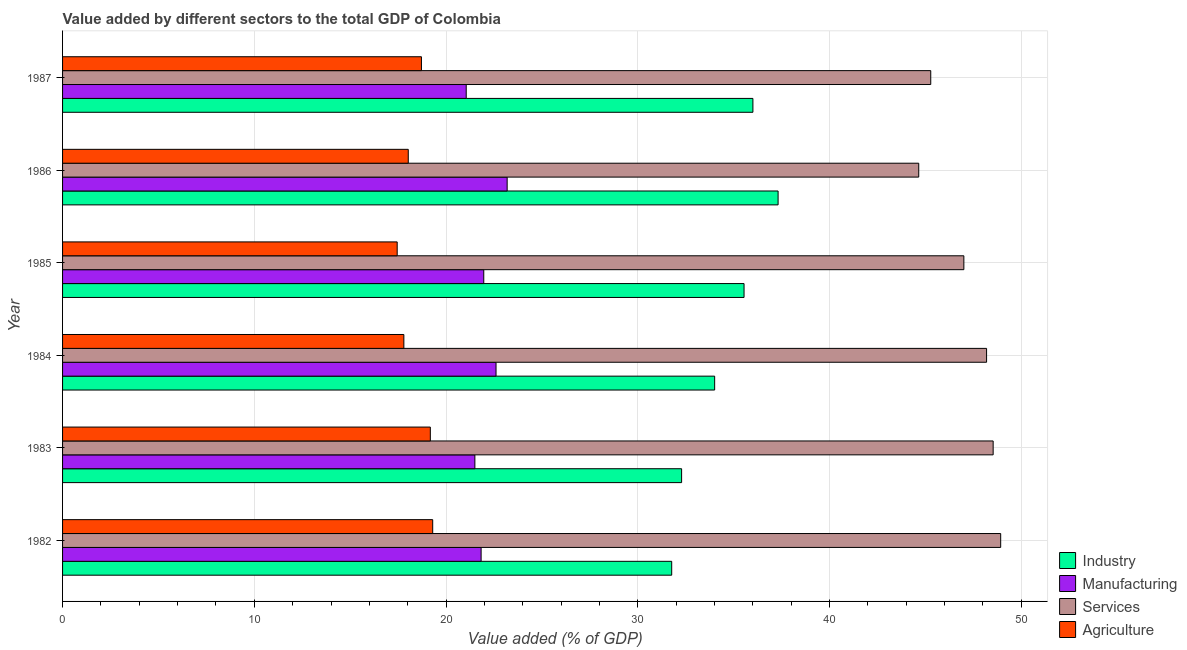How many different coloured bars are there?
Offer a terse response. 4. How many groups of bars are there?
Your answer should be very brief. 6. How many bars are there on the 3rd tick from the top?
Offer a terse response. 4. How many bars are there on the 5th tick from the bottom?
Give a very brief answer. 4. What is the label of the 2nd group of bars from the top?
Offer a terse response. 1986. In how many cases, is the number of bars for a given year not equal to the number of legend labels?
Give a very brief answer. 0. What is the value added by agricultural sector in 1983?
Offer a terse response. 19.18. Across all years, what is the maximum value added by services sector?
Make the answer very short. 48.93. Across all years, what is the minimum value added by services sector?
Ensure brevity in your answer.  44.65. In which year was the value added by agricultural sector maximum?
Your response must be concise. 1982. What is the total value added by industrial sector in the graph?
Offer a terse response. 206.93. What is the difference between the value added by services sector in 1982 and that in 1984?
Give a very brief answer. 0.74. What is the difference between the value added by services sector in 1985 and the value added by industrial sector in 1983?
Your answer should be very brief. 14.72. What is the average value added by services sector per year?
Make the answer very short. 47.1. In the year 1987, what is the difference between the value added by manufacturing sector and value added by industrial sector?
Make the answer very short. -14.95. What is the ratio of the value added by services sector in 1982 to that in 1987?
Ensure brevity in your answer.  1.08. Is the value added by manufacturing sector in 1985 less than that in 1987?
Your answer should be compact. No. Is the difference between the value added by services sector in 1984 and 1987 greater than the difference between the value added by industrial sector in 1984 and 1987?
Your answer should be very brief. Yes. What is the difference between the highest and the second highest value added by agricultural sector?
Give a very brief answer. 0.12. What is the difference between the highest and the lowest value added by manufacturing sector?
Provide a short and direct response. 2.14. In how many years, is the value added by manufacturing sector greater than the average value added by manufacturing sector taken over all years?
Give a very brief answer. 2. Is the sum of the value added by agricultural sector in 1983 and 1987 greater than the maximum value added by services sector across all years?
Provide a short and direct response. No. Is it the case that in every year, the sum of the value added by services sector and value added by manufacturing sector is greater than the sum of value added by industrial sector and value added by agricultural sector?
Keep it short and to the point. No. What does the 1st bar from the top in 1987 represents?
Provide a short and direct response. Agriculture. What does the 3rd bar from the bottom in 1982 represents?
Give a very brief answer. Services. Are all the bars in the graph horizontal?
Give a very brief answer. Yes. Are the values on the major ticks of X-axis written in scientific E-notation?
Your answer should be compact. No. Does the graph contain any zero values?
Your answer should be very brief. No. Where does the legend appear in the graph?
Give a very brief answer. Bottom right. How many legend labels are there?
Your response must be concise. 4. How are the legend labels stacked?
Provide a succinct answer. Vertical. What is the title of the graph?
Offer a very short reply. Value added by different sectors to the total GDP of Colombia. What is the label or title of the X-axis?
Provide a succinct answer. Value added (% of GDP). What is the Value added (% of GDP) in Industry in 1982?
Your answer should be compact. 31.77. What is the Value added (% of GDP) in Manufacturing in 1982?
Provide a short and direct response. 21.83. What is the Value added (% of GDP) in Services in 1982?
Ensure brevity in your answer.  48.93. What is the Value added (% of GDP) in Agriculture in 1982?
Your answer should be compact. 19.3. What is the Value added (% of GDP) of Industry in 1983?
Provide a succinct answer. 32.29. What is the Value added (% of GDP) in Manufacturing in 1983?
Offer a very short reply. 21.5. What is the Value added (% of GDP) of Services in 1983?
Offer a terse response. 48.53. What is the Value added (% of GDP) in Agriculture in 1983?
Provide a succinct answer. 19.18. What is the Value added (% of GDP) of Industry in 1984?
Your answer should be very brief. 34.01. What is the Value added (% of GDP) in Manufacturing in 1984?
Your response must be concise. 22.61. What is the Value added (% of GDP) of Services in 1984?
Offer a terse response. 48.19. What is the Value added (% of GDP) in Agriculture in 1984?
Offer a terse response. 17.8. What is the Value added (% of GDP) in Industry in 1985?
Give a very brief answer. 35.54. What is the Value added (% of GDP) of Manufacturing in 1985?
Ensure brevity in your answer.  21.97. What is the Value added (% of GDP) in Services in 1985?
Your answer should be compact. 47.01. What is the Value added (% of GDP) in Agriculture in 1985?
Make the answer very short. 17.45. What is the Value added (% of GDP) of Industry in 1986?
Your answer should be very brief. 37.32. What is the Value added (% of GDP) of Manufacturing in 1986?
Offer a terse response. 23.19. What is the Value added (% of GDP) of Services in 1986?
Offer a terse response. 44.65. What is the Value added (% of GDP) of Agriculture in 1986?
Give a very brief answer. 18.03. What is the Value added (% of GDP) of Industry in 1987?
Provide a succinct answer. 36. What is the Value added (% of GDP) in Manufacturing in 1987?
Your answer should be compact. 21.05. What is the Value added (% of GDP) of Services in 1987?
Offer a very short reply. 45.28. What is the Value added (% of GDP) in Agriculture in 1987?
Provide a short and direct response. 18.72. Across all years, what is the maximum Value added (% of GDP) in Industry?
Ensure brevity in your answer.  37.32. Across all years, what is the maximum Value added (% of GDP) of Manufacturing?
Offer a terse response. 23.19. Across all years, what is the maximum Value added (% of GDP) in Services?
Ensure brevity in your answer.  48.93. Across all years, what is the maximum Value added (% of GDP) in Agriculture?
Your answer should be very brief. 19.3. Across all years, what is the minimum Value added (% of GDP) in Industry?
Make the answer very short. 31.77. Across all years, what is the minimum Value added (% of GDP) of Manufacturing?
Provide a succinct answer. 21.05. Across all years, what is the minimum Value added (% of GDP) of Services?
Your response must be concise. 44.65. Across all years, what is the minimum Value added (% of GDP) of Agriculture?
Ensure brevity in your answer.  17.45. What is the total Value added (% of GDP) of Industry in the graph?
Your answer should be compact. 206.93. What is the total Value added (% of GDP) of Manufacturing in the graph?
Give a very brief answer. 132.15. What is the total Value added (% of GDP) of Services in the graph?
Offer a terse response. 282.59. What is the total Value added (% of GDP) in Agriculture in the graph?
Give a very brief answer. 110.48. What is the difference between the Value added (% of GDP) in Industry in 1982 and that in 1983?
Make the answer very short. -0.52. What is the difference between the Value added (% of GDP) of Manufacturing in 1982 and that in 1983?
Offer a very short reply. 0.33. What is the difference between the Value added (% of GDP) in Services in 1982 and that in 1983?
Ensure brevity in your answer.  0.39. What is the difference between the Value added (% of GDP) in Agriculture in 1982 and that in 1983?
Provide a succinct answer. 0.12. What is the difference between the Value added (% of GDP) in Industry in 1982 and that in 1984?
Provide a short and direct response. -2.24. What is the difference between the Value added (% of GDP) in Manufacturing in 1982 and that in 1984?
Offer a terse response. -0.78. What is the difference between the Value added (% of GDP) of Services in 1982 and that in 1984?
Provide a short and direct response. 0.74. What is the difference between the Value added (% of GDP) of Agriculture in 1982 and that in 1984?
Give a very brief answer. 1.5. What is the difference between the Value added (% of GDP) in Industry in 1982 and that in 1985?
Make the answer very short. -3.77. What is the difference between the Value added (% of GDP) in Manufacturing in 1982 and that in 1985?
Offer a terse response. -0.14. What is the difference between the Value added (% of GDP) of Services in 1982 and that in 1985?
Your answer should be very brief. 1.92. What is the difference between the Value added (% of GDP) of Agriculture in 1982 and that in 1985?
Your response must be concise. 1.85. What is the difference between the Value added (% of GDP) in Industry in 1982 and that in 1986?
Keep it short and to the point. -5.55. What is the difference between the Value added (% of GDP) in Manufacturing in 1982 and that in 1986?
Your answer should be very brief. -1.36. What is the difference between the Value added (% of GDP) of Services in 1982 and that in 1986?
Offer a terse response. 4.27. What is the difference between the Value added (% of GDP) of Agriculture in 1982 and that in 1986?
Your answer should be compact. 1.27. What is the difference between the Value added (% of GDP) in Industry in 1982 and that in 1987?
Offer a terse response. -4.23. What is the difference between the Value added (% of GDP) in Manufacturing in 1982 and that in 1987?
Offer a terse response. 0.78. What is the difference between the Value added (% of GDP) of Services in 1982 and that in 1987?
Keep it short and to the point. 3.65. What is the difference between the Value added (% of GDP) of Agriculture in 1982 and that in 1987?
Your answer should be very brief. 0.59. What is the difference between the Value added (% of GDP) of Industry in 1983 and that in 1984?
Your response must be concise. -1.72. What is the difference between the Value added (% of GDP) in Manufacturing in 1983 and that in 1984?
Give a very brief answer. -1.1. What is the difference between the Value added (% of GDP) of Services in 1983 and that in 1984?
Give a very brief answer. 0.34. What is the difference between the Value added (% of GDP) of Agriculture in 1983 and that in 1984?
Offer a very short reply. 1.38. What is the difference between the Value added (% of GDP) of Industry in 1983 and that in 1985?
Give a very brief answer. -3.26. What is the difference between the Value added (% of GDP) of Manufacturing in 1983 and that in 1985?
Your answer should be compact. -0.46. What is the difference between the Value added (% of GDP) in Services in 1983 and that in 1985?
Give a very brief answer. 1.53. What is the difference between the Value added (% of GDP) of Agriculture in 1983 and that in 1985?
Your response must be concise. 1.73. What is the difference between the Value added (% of GDP) of Industry in 1983 and that in 1986?
Keep it short and to the point. -5.03. What is the difference between the Value added (% of GDP) in Manufacturing in 1983 and that in 1986?
Provide a succinct answer. -1.68. What is the difference between the Value added (% of GDP) of Services in 1983 and that in 1986?
Give a very brief answer. 3.88. What is the difference between the Value added (% of GDP) in Agriculture in 1983 and that in 1986?
Your answer should be compact. 1.15. What is the difference between the Value added (% of GDP) in Industry in 1983 and that in 1987?
Your answer should be very brief. -3.72. What is the difference between the Value added (% of GDP) of Manufacturing in 1983 and that in 1987?
Ensure brevity in your answer.  0.45. What is the difference between the Value added (% of GDP) in Services in 1983 and that in 1987?
Your response must be concise. 3.26. What is the difference between the Value added (% of GDP) in Agriculture in 1983 and that in 1987?
Make the answer very short. 0.46. What is the difference between the Value added (% of GDP) in Industry in 1984 and that in 1985?
Your answer should be very brief. -1.53. What is the difference between the Value added (% of GDP) in Manufacturing in 1984 and that in 1985?
Ensure brevity in your answer.  0.64. What is the difference between the Value added (% of GDP) in Services in 1984 and that in 1985?
Make the answer very short. 1.19. What is the difference between the Value added (% of GDP) of Agriculture in 1984 and that in 1985?
Ensure brevity in your answer.  0.35. What is the difference between the Value added (% of GDP) in Industry in 1984 and that in 1986?
Provide a short and direct response. -3.31. What is the difference between the Value added (% of GDP) of Manufacturing in 1984 and that in 1986?
Provide a short and direct response. -0.58. What is the difference between the Value added (% of GDP) in Services in 1984 and that in 1986?
Ensure brevity in your answer.  3.54. What is the difference between the Value added (% of GDP) in Agriculture in 1984 and that in 1986?
Your answer should be very brief. -0.23. What is the difference between the Value added (% of GDP) in Industry in 1984 and that in 1987?
Your response must be concise. -1.99. What is the difference between the Value added (% of GDP) of Manufacturing in 1984 and that in 1987?
Provide a succinct answer. 1.56. What is the difference between the Value added (% of GDP) in Services in 1984 and that in 1987?
Your response must be concise. 2.91. What is the difference between the Value added (% of GDP) in Agriculture in 1984 and that in 1987?
Give a very brief answer. -0.92. What is the difference between the Value added (% of GDP) of Industry in 1985 and that in 1986?
Make the answer very short. -1.78. What is the difference between the Value added (% of GDP) of Manufacturing in 1985 and that in 1986?
Provide a succinct answer. -1.22. What is the difference between the Value added (% of GDP) in Services in 1985 and that in 1986?
Offer a very short reply. 2.35. What is the difference between the Value added (% of GDP) in Agriculture in 1985 and that in 1986?
Your answer should be very brief. -0.58. What is the difference between the Value added (% of GDP) of Industry in 1985 and that in 1987?
Provide a short and direct response. -0.46. What is the difference between the Value added (% of GDP) in Manufacturing in 1985 and that in 1987?
Ensure brevity in your answer.  0.92. What is the difference between the Value added (% of GDP) of Services in 1985 and that in 1987?
Your answer should be compact. 1.73. What is the difference between the Value added (% of GDP) of Agriculture in 1985 and that in 1987?
Your answer should be very brief. -1.26. What is the difference between the Value added (% of GDP) of Industry in 1986 and that in 1987?
Ensure brevity in your answer.  1.31. What is the difference between the Value added (% of GDP) of Manufacturing in 1986 and that in 1987?
Your answer should be very brief. 2.14. What is the difference between the Value added (% of GDP) of Services in 1986 and that in 1987?
Offer a very short reply. -0.63. What is the difference between the Value added (% of GDP) in Agriculture in 1986 and that in 1987?
Keep it short and to the point. -0.69. What is the difference between the Value added (% of GDP) in Industry in 1982 and the Value added (% of GDP) in Manufacturing in 1983?
Your response must be concise. 10.27. What is the difference between the Value added (% of GDP) in Industry in 1982 and the Value added (% of GDP) in Services in 1983?
Your response must be concise. -16.77. What is the difference between the Value added (% of GDP) of Industry in 1982 and the Value added (% of GDP) of Agriculture in 1983?
Your answer should be very brief. 12.59. What is the difference between the Value added (% of GDP) in Manufacturing in 1982 and the Value added (% of GDP) in Services in 1983?
Offer a terse response. -26.71. What is the difference between the Value added (% of GDP) in Manufacturing in 1982 and the Value added (% of GDP) in Agriculture in 1983?
Your response must be concise. 2.65. What is the difference between the Value added (% of GDP) of Services in 1982 and the Value added (% of GDP) of Agriculture in 1983?
Your answer should be compact. 29.75. What is the difference between the Value added (% of GDP) of Industry in 1982 and the Value added (% of GDP) of Manufacturing in 1984?
Your response must be concise. 9.16. What is the difference between the Value added (% of GDP) of Industry in 1982 and the Value added (% of GDP) of Services in 1984?
Provide a short and direct response. -16.42. What is the difference between the Value added (% of GDP) in Industry in 1982 and the Value added (% of GDP) in Agriculture in 1984?
Provide a short and direct response. 13.97. What is the difference between the Value added (% of GDP) of Manufacturing in 1982 and the Value added (% of GDP) of Services in 1984?
Offer a very short reply. -26.36. What is the difference between the Value added (% of GDP) in Manufacturing in 1982 and the Value added (% of GDP) in Agriculture in 1984?
Keep it short and to the point. 4.03. What is the difference between the Value added (% of GDP) in Services in 1982 and the Value added (% of GDP) in Agriculture in 1984?
Keep it short and to the point. 31.13. What is the difference between the Value added (% of GDP) of Industry in 1982 and the Value added (% of GDP) of Manufacturing in 1985?
Offer a very short reply. 9.8. What is the difference between the Value added (% of GDP) in Industry in 1982 and the Value added (% of GDP) in Services in 1985?
Offer a terse response. -15.24. What is the difference between the Value added (% of GDP) in Industry in 1982 and the Value added (% of GDP) in Agriculture in 1985?
Make the answer very short. 14.32. What is the difference between the Value added (% of GDP) in Manufacturing in 1982 and the Value added (% of GDP) in Services in 1985?
Ensure brevity in your answer.  -25.18. What is the difference between the Value added (% of GDP) of Manufacturing in 1982 and the Value added (% of GDP) of Agriculture in 1985?
Your response must be concise. 4.38. What is the difference between the Value added (% of GDP) of Services in 1982 and the Value added (% of GDP) of Agriculture in 1985?
Ensure brevity in your answer.  31.48. What is the difference between the Value added (% of GDP) of Industry in 1982 and the Value added (% of GDP) of Manufacturing in 1986?
Make the answer very short. 8.58. What is the difference between the Value added (% of GDP) of Industry in 1982 and the Value added (% of GDP) of Services in 1986?
Make the answer very short. -12.88. What is the difference between the Value added (% of GDP) in Industry in 1982 and the Value added (% of GDP) in Agriculture in 1986?
Your answer should be compact. 13.74. What is the difference between the Value added (% of GDP) of Manufacturing in 1982 and the Value added (% of GDP) of Services in 1986?
Your answer should be compact. -22.82. What is the difference between the Value added (% of GDP) of Manufacturing in 1982 and the Value added (% of GDP) of Agriculture in 1986?
Offer a terse response. 3.8. What is the difference between the Value added (% of GDP) in Services in 1982 and the Value added (% of GDP) in Agriculture in 1986?
Keep it short and to the point. 30.9. What is the difference between the Value added (% of GDP) in Industry in 1982 and the Value added (% of GDP) in Manufacturing in 1987?
Keep it short and to the point. 10.72. What is the difference between the Value added (% of GDP) in Industry in 1982 and the Value added (% of GDP) in Services in 1987?
Make the answer very short. -13.51. What is the difference between the Value added (% of GDP) in Industry in 1982 and the Value added (% of GDP) in Agriculture in 1987?
Give a very brief answer. 13.05. What is the difference between the Value added (% of GDP) of Manufacturing in 1982 and the Value added (% of GDP) of Services in 1987?
Provide a succinct answer. -23.45. What is the difference between the Value added (% of GDP) of Manufacturing in 1982 and the Value added (% of GDP) of Agriculture in 1987?
Make the answer very short. 3.11. What is the difference between the Value added (% of GDP) of Services in 1982 and the Value added (% of GDP) of Agriculture in 1987?
Ensure brevity in your answer.  30.21. What is the difference between the Value added (% of GDP) of Industry in 1983 and the Value added (% of GDP) of Manufacturing in 1984?
Provide a short and direct response. 9.68. What is the difference between the Value added (% of GDP) of Industry in 1983 and the Value added (% of GDP) of Services in 1984?
Your answer should be compact. -15.91. What is the difference between the Value added (% of GDP) in Industry in 1983 and the Value added (% of GDP) in Agriculture in 1984?
Your answer should be very brief. 14.49. What is the difference between the Value added (% of GDP) in Manufacturing in 1983 and the Value added (% of GDP) in Services in 1984?
Offer a terse response. -26.69. What is the difference between the Value added (% of GDP) in Manufacturing in 1983 and the Value added (% of GDP) in Agriculture in 1984?
Provide a succinct answer. 3.7. What is the difference between the Value added (% of GDP) in Services in 1983 and the Value added (% of GDP) in Agriculture in 1984?
Ensure brevity in your answer.  30.73. What is the difference between the Value added (% of GDP) of Industry in 1983 and the Value added (% of GDP) of Manufacturing in 1985?
Ensure brevity in your answer.  10.32. What is the difference between the Value added (% of GDP) of Industry in 1983 and the Value added (% of GDP) of Services in 1985?
Ensure brevity in your answer.  -14.72. What is the difference between the Value added (% of GDP) in Industry in 1983 and the Value added (% of GDP) in Agriculture in 1985?
Your answer should be compact. 14.83. What is the difference between the Value added (% of GDP) of Manufacturing in 1983 and the Value added (% of GDP) of Services in 1985?
Make the answer very short. -25.5. What is the difference between the Value added (% of GDP) in Manufacturing in 1983 and the Value added (% of GDP) in Agriculture in 1985?
Make the answer very short. 4.05. What is the difference between the Value added (% of GDP) of Services in 1983 and the Value added (% of GDP) of Agriculture in 1985?
Your answer should be very brief. 31.08. What is the difference between the Value added (% of GDP) of Industry in 1983 and the Value added (% of GDP) of Manufacturing in 1986?
Offer a terse response. 9.1. What is the difference between the Value added (% of GDP) of Industry in 1983 and the Value added (% of GDP) of Services in 1986?
Ensure brevity in your answer.  -12.37. What is the difference between the Value added (% of GDP) in Industry in 1983 and the Value added (% of GDP) in Agriculture in 1986?
Give a very brief answer. 14.26. What is the difference between the Value added (% of GDP) of Manufacturing in 1983 and the Value added (% of GDP) of Services in 1986?
Your answer should be compact. -23.15. What is the difference between the Value added (% of GDP) of Manufacturing in 1983 and the Value added (% of GDP) of Agriculture in 1986?
Provide a short and direct response. 3.47. What is the difference between the Value added (% of GDP) of Services in 1983 and the Value added (% of GDP) of Agriculture in 1986?
Your response must be concise. 30.5. What is the difference between the Value added (% of GDP) of Industry in 1983 and the Value added (% of GDP) of Manufacturing in 1987?
Provide a succinct answer. 11.23. What is the difference between the Value added (% of GDP) in Industry in 1983 and the Value added (% of GDP) in Services in 1987?
Your response must be concise. -12.99. What is the difference between the Value added (% of GDP) in Industry in 1983 and the Value added (% of GDP) in Agriculture in 1987?
Ensure brevity in your answer.  13.57. What is the difference between the Value added (% of GDP) in Manufacturing in 1983 and the Value added (% of GDP) in Services in 1987?
Provide a short and direct response. -23.78. What is the difference between the Value added (% of GDP) in Manufacturing in 1983 and the Value added (% of GDP) in Agriculture in 1987?
Provide a short and direct response. 2.79. What is the difference between the Value added (% of GDP) of Services in 1983 and the Value added (% of GDP) of Agriculture in 1987?
Make the answer very short. 29.82. What is the difference between the Value added (% of GDP) of Industry in 1984 and the Value added (% of GDP) of Manufacturing in 1985?
Keep it short and to the point. 12.04. What is the difference between the Value added (% of GDP) in Industry in 1984 and the Value added (% of GDP) in Services in 1985?
Offer a terse response. -13. What is the difference between the Value added (% of GDP) of Industry in 1984 and the Value added (% of GDP) of Agriculture in 1985?
Give a very brief answer. 16.56. What is the difference between the Value added (% of GDP) of Manufacturing in 1984 and the Value added (% of GDP) of Services in 1985?
Provide a short and direct response. -24.4. What is the difference between the Value added (% of GDP) in Manufacturing in 1984 and the Value added (% of GDP) in Agriculture in 1985?
Provide a succinct answer. 5.16. What is the difference between the Value added (% of GDP) in Services in 1984 and the Value added (% of GDP) in Agriculture in 1985?
Offer a terse response. 30.74. What is the difference between the Value added (% of GDP) of Industry in 1984 and the Value added (% of GDP) of Manufacturing in 1986?
Make the answer very short. 10.82. What is the difference between the Value added (% of GDP) in Industry in 1984 and the Value added (% of GDP) in Services in 1986?
Offer a very short reply. -10.64. What is the difference between the Value added (% of GDP) in Industry in 1984 and the Value added (% of GDP) in Agriculture in 1986?
Your response must be concise. 15.98. What is the difference between the Value added (% of GDP) in Manufacturing in 1984 and the Value added (% of GDP) in Services in 1986?
Your response must be concise. -22.05. What is the difference between the Value added (% of GDP) of Manufacturing in 1984 and the Value added (% of GDP) of Agriculture in 1986?
Your answer should be very brief. 4.58. What is the difference between the Value added (% of GDP) of Services in 1984 and the Value added (% of GDP) of Agriculture in 1986?
Provide a short and direct response. 30.16. What is the difference between the Value added (% of GDP) in Industry in 1984 and the Value added (% of GDP) in Manufacturing in 1987?
Ensure brevity in your answer.  12.96. What is the difference between the Value added (% of GDP) in Industry in 1984 and the Value added (% of GDP) in Services in 1987?
Your answer should be compact. -11.27. What is the difference between the Value added (% of GDP) in Industry in 1984 and the Value added (% of GDP) in Agriculture in 1987?
Your answer should be compact. 15.29. What is the difference between the Value added (% of GDP) of Manufacturing in 1984 and the Value added (% of GDP) of Services in 1987?
Your answer should be compact. -22.67. What is the difference between the Value added (% of GDP) of Manufacturing in 1984 and the Value added (% of GDP) of Agriculture in 1987?
Offer a very short reply. 3.89. What is the difference between the Value added (% of GDP) in Services in 1984 and the Value added (% of GDP) in Agriculture in 1987?
Ensure brevity in your answer.  29.47. What is the difference between the Value added (% of GDP) of Industry in 1985 and the Value added (% of GDP) of Manufacturing in 1986?
Your answer should be compact. 12.35. What is the difference between the Value added (% of GDP) of Industry in 1985 and the Value added (% of GDP) of Services in 1986?
Ensure brevity in your answer.  -9.11. What is the difference between the Value added (% of GDP) in Industry in 1985 and the Value added (% of GDP) in Agriculture in 1986?
Offer a terse response. 17.51. What is the difference between the Value added (% of GDP) in Manufacturing in 1985 and the Value added (% of GDP) in Services in 1986?
Offer a very short reply. -22.69. What is the difference between the Value added (% of GDP) in Manufacturing in 1985 and the Value added (% of GDP) in Agriculture in 1986?
Offer a terse response. 3.94. What is the difference between the Value added (% of GDP) in Services in 1985 and the Value added (% of GDP) in Agriculture in 1986?
Offer a terse response. 28.98. What is the difference between the Value added (% of GDP) of Industry in 1985 and the Value added (% of GDP) of Manufacturing in 1987?
Give a very brief answer. 14.49. What is the difference between the Value added (% of GDP) of Industry in 1985 and the Value added (% of GDP) of Services in 1987?
Your answer should be very brief. -9.74. What is the difference between the Value added (% of GDP) in Industry in 1985 and the Value added (% of GDP) in Agriculture in 1987?
Keep it short and to the point. 16.83. What is the difference between the Value added (% of GDP) of Manufacturing in 1985 and the Value added (% of GDP) of Services in 1987?
Offer a terse response. -23.31. What is the difference between the Value added (% of GDP) in Manufacturing in 1985 and the Value added (% of GDP) in Agriculture in 1987?
Offer a terse response. 3.25. What is the difference between the Value added (% of GDP) in Services in 1985 and the Value added (% of GDP) in Agriculture in 1987?
Provide a succinct answer. 28.29. What is the difference between the Value added (% of GDP) in Industry in 1986 and the Value added (% of GDP) in Manufacturing in 1987?
Keep it short and to the point. 16.27. What is the difference between the Value added (% of GDP) in Industry in 1986 and the Value added (% of GDP) in Services in 1987?
Keep it short and to the point. -7.96. What is the difference between the Value added (% of GDP) of Industry in 1986 and the Value added (% of GDP) of Agriculture in 1987?
Keep it short and to the point. 18.6. What is the difference between the Value added (% of GDP) in Manufacturing in 1986 and the Value added (% of GDP) in Services in 1987?
Provide a succinct answer. -22.09. What is the difference between the Value added (% of GDP) of Manufacturing in 1986 and the Value added (% of GDP) of Agriculture in 1987?
Provide a short and direct response. 4.47. What is the difference between the Value added (% of GDP) of Services in 1986 and the Value added (% of GDP) of Agriculture in 1987?
Give a very brief answer. 25.94. What is the average Value added (% of GDP) of Industry per year?
Your answer should be compact. 34.49. What is the average Value added (% of GDP) of Manufacturing per year?
Offer a terse response. 22.02. What is the average Value added (% of GDP) of Services per year?
Ensure brevity in your answer.  47.1. What is the average Value added (% of GDP) in Agriculture per year?
Provide a short and direct response. 18.41. In the year 1982, what is the difference between the Value added (% of GDP) of Industry and Value added (% of GDP) of Manufacturing?
Ensure brevity in your answer.  9.94. In the year 1982, what is the difference between the Value added (% of GDP) in Industry and Value added (% of GDP) in Services?
Ensure brevity in your answer.  -17.16. In the year 1982, what is the difference between the Value added (% of GDP) of Industry and Value added (% of GDP) of Agriculture?
Offer a terse response. 12.47. In the year 1982, what is the difference between the Value added (% of GDP) in Manufacturing and Value added (% of GDP) in Services?
Keep it short and to the point. -27.1. In the year 1982, what is the difference between the Value added (% of GDP) in Manufacturing and Value added (% of GDP) in Agriculture?
Your answer should be compact. 2.53. In the year 1982, what is the difference between the Value added (% of GDP) in Services and Value added (% of GDP) in Agriculture?
Make the answer very short. 29.62. In the year 1983, what is the difference between the Value added (% of GDP) in Industry and Value added (% of GDP) in Manufacturing?
Offer a very short reply. 10.78. In the year 1983, what is the difference between the Value added (% of GDP) of Industry and Value added (% of GDP) of Services?
Provide a short and direct response. -16.25. In the year 1983, what is the difference between the Value added (% of GDP) of Industry and Value added (% of GDP) of Agriculture?
Give a very brief answer. 13.11. In the year 1983, what is the difference between the Value added (% of GDP) of Manufacturing and Value added (% of GDP) of Services?
Give a very brief answer. -27.03. In the year 1983, what is the difference between the Value added (% of GDP) of Manufacturing and Value added (% of GDP) of Agriculture?
Your response must be concise. 2.32. In the year 1983, what is the difference between the Value added (% of GDP) of Services and Value added (% of GDP) of Agriculture?
Ensure brevity in your answer.  29.35. In the year 1984, what is the difference between the Value added (% of GDP) of Industry and Value added (% of GDP) of Manufacturing?
Your answer should be compact. 11.4. In the year 1984, what is the difference between the Value added (% of GDP) in Industry and Value added (% of GDP) in Services?
Offer a very short reply. -14.18. In the year 1984, what is the difference between the Value added (% of GDP) of Industry and Value added (% of GDP) of Agriculture?
Give a very brief answer. 16.21. In the year 1984, what is the difference between the Value added (% of GDP) of Manufacturing and Value added (% of GDP) of Services?
Provide a short and direct response. -25.58. In the year 1984, what is the difference between the Value added (% of GDP) of Manufacturing and Value added (% of GDP) of Agriculture?
Provide a succinct answer. 4.81. In the year 1984, what is the difference between the Value added (% of GDP) in Services and Value added (% of GDP) in Agriculture?
Your response must be concise. 30.39. In the year 1985, what is the difference between the Value added (% of GDP) of Industry and Value added (% of GDP) of Manufacturing?
Ensure brevity in your answer.  13.58. In the year 1985, what is the difference between the Value added (% of GDP) of Industry and Value added (% of GDP) of Services?
Offer a very short reply. -11.46. In the year 1985, what is the difference between the Value added (% of GDP) in Industry and Value added (% of GDP) in Agriculture?
Provide a succinct answer. 18.09. In the year 1985, what is the difference between the Value added (% of GDP) of Manufacturing and Value added (% of GDP) of Services?
Your answer should be very brief. -25.04. In the year 1985, what is the difference between the Value added (% of GDP) of Manufacturing and Value added (% of GDP) of Agriculture?
Ensure brevity in your answer.  4.52. In the year 1985, what is the difference between the Value added (% of GDP) in Services and Value added (% of GDP) in Agriculture?
Offer a terse response. 29.55. In the year 1986, what is the difference between the Value added (% of GDP) of Industry and Value added (% of GDP) of Manufacturing?
Keep it short and to the point. 14.13. In the year 1986, what is the difference between the Value added (% of GDP) in Industry and Value added (% of GDP) in Services?
Your answer should be very brief. -7.33. In the year 1986, what is the difference between the Value added (% of GDP) in Industry and Value added (% of GDP) in Agriculture?
Offer a terse response. 19.29. In the year 1986, what is the difference between the Value added (% of GDP) in Manufacturing and Value added (% of GDP) in Services?
Provide a succinct answer. -21.46. In the year 1986, what is the difference between the Value added (% of GDP) in Manufacturing and Value added (% of GDP) in Agriculture?
Give a very brief answer. 5.16. In the year 1986, what is the difference between the Value added (% of GDP) of Services and Value added (% of GDP) of Agriculture?
Your answer should be very brief. 26.62. In the year 1987, what is the difference between the Value added (% of GDP) in Industry and Value added (% of GDP) in Manufacturing?
Offer a terse response. 14.95. In the year 1987, what is the difference between the Value added (% of GDP) in Industry and Value added (% of GDP) in Services?
Keep it short and to the point. -9.28. In the year 1987, what is the difference between the Value added (% of GDP) of Industry and Value added (% of GDP) of Agriculture?
Provide a succinct answer. 17.29. In the year 1987, what is the difference between the Value added (% of GDP) of Manufacturing and Value added (% of GDP) of Services?
Offer a terse response. -24.23. In the year 1987, what is the difference between the Value added (% of GDP) in Manufacturing and Value added (% of GDP) in Agriculture?
Offer a terse response. 2.34. In the year 1987, what is the difference between the Value added (% of GDP) of Services and Value added (% of GDP) of Agriculture?
Your response must be concise. 26.56. What is the ratio of the Value added (% of GDP) of Industry in 1982 to that in 1983?
Provide a short and direct response. 0.98. What is the ratio of the Value added (% of GDP) in Manufacturing in 1982 to that in 1983?
Offer a very short reply. 1.02. What is the ratio of the Value added (% of GDP) of Services in 1982 to that in 1983?
Provide a short and direct response. 1.01. What is the ratio of the Value added (% of GDP) in Industry in 1982 to that in 1984?
Your answer should be compact. 0.93. What is the ratio of the Value added (% of GDP) in Manufacturing in 1982 to that in 1984?
Offer a terse response. 0.97. What is the ratio of the Value added (% of GDP) of Services in 1982 to that in 1984?
Your answer should be very brief. 1.02. What is the ratio of the Value added (% of GDP) in Agriculture in 1982 to that in 1984?
Offer a terse response. 1.08. What is the ratio of the Value added (% of GDP) of Industry in 1982 to that in 1985?
Ensure brevity in your answer.  0.89. What is the ratio of the Value added (% of GDP) of Services in 1982 to that in 1985?
Offer a very short reply. 1.04. What is the ratio of the Value added (% of GDP) in Agriculture in 1982 to that in 1985?
Ensure brevity in your answer.  1.11. What is the ratio of the Value added (% of GDP) in Industry in 1982 to that in 1986?
Your answer should be very brief. 0.85. What is the ratio of the Value added (% of GDP) in Manufacturing in 1982 to that in 1986?
Give a very brief answer. 0.94. What is the ratio of the Value added (% of GDP) in Services in 1982 to that in 1986?
Keep it short and to the point. 1.1. What is the ratio of the Value added (% of GDP) of Agriculture in 1982 to that in 1986?
Your answer should be very brief. 1.07. What is the ratio of the Value added (% of GDP) of Industry in 1982 to that in 1987?
Give a very brief answer. 0.88. What is the ratio of the Value added (% of GDP) of Manufacturing in 1982 to that in 1987?
Your answer should be very brief. 1.04. What is the ratio of the Value added (% of GDP) of Services in 1982 to that in 1987?
Provide a succinct answer. 1.08. What is the ratio of the Value added (% of GDP) in Agriculture in 1982 to that in 1987?
Your response must be concise. 1.03. What is the ratio of the Value added (% of GDP) in Industry in 1983 to that in 1984?
Provide a short and direct response. 0.95. What is the ratio of the Value added (% of GDP) of Manufacturing in 1983 to that in 1984?
Your answer should be compact. 0.95. What is the ratio of the Value added (% of GDP) in Services in 1983 to that in 1984?
Keep it short and to the point. 1.01. What is the ratio of the Value added (% of GDP) in Agriculture in 1983 to that in 1984?
Offer a terse response. 1.08. What is the ratio of the Value added (% of GDP) of Industry in 1983 to that in 1985?
Offer a terse response. 0.91. What is the ratio of the Value added (% of GDP) of Manufacturing in 1983 to that in 1985?
Make the answer very short. 0.98. What is the ratio of the Value added (% of GDP) in Services in 1983 to that in 1985?
Your response must be concise. 1.03. What is the ratio of the Value added (% of GDP) in Agriculture in 1983 to that in 1985?
Your answer should be very brief. 1.1. What is the ratio of the Value added (% of GDP) of Industry in 1983 to that in 1986?
Your answer should be compact. 0.87. What is the ratio of the Value added (% of GDP) of Manufacturing in 1983 to that in 1986?
Offer a terse response. 0.93. What is the ratio of the Value added (% of GDP) in Services in 1983 to that in 1986?
Your answer should be very brief. 1.09. What is the ratio of the Value added (% of GDP) of Agriculture in 1983 to that in 1986?
Provide a short and direct response. 1.06. What is the ratio of the Value added (% of GDP) in Industry in 1983 to that in 1987?
Offer a terse response. 0.9. What is the ratio of the Value added (% of GDP) of Manufacturing in 1983 to that in 1987?
Your answer should be compact. 1.02. What is the ratio of the Value added (% of GDP) in Services in 1983 to that in 1987?
Your response must be concise. 1.07. What is the ratio of the Value added (% of GDP) of Agriculture in 1983 to that in 1987?
Offer a very short reply. 1.02. What is the ratio of the Value added (% of GDP) of Industry in 1984 to that in 1985?
Provide a succinct answer. 0.96. What is the ratio of the Value added (% of GDP) in Manufacturing in 1984 to that in 1985?
Keep it short and to the point. 1.03. What is the ratio of the Value added (% of GDP) in Services in 1984 to that in 1985?
Your answer should be compact. 1.03. What is the ratio of the Value added (% of GDP) in Industry in 1984 to that in 1986?
Provide a succinct answer. 0.91. What is the ratio of the Value added (% of GDP) of Manufacturing in 1984 to that in 1986?
Keep it short and to the point. 0.97. What is the ratio of the Value added (% of GDP) of Services in 1984 to that in 1986?
Give a very brief answer. 1.08. What is the ratio of the Value added (% of GDP) in Agriculture in 1984 to that in 1986?
Your response must be concise. 0.99. What is the ratio of the Value added (% of GDP) of Industry in 1984 to that in 1987?
Ensure brevity in your answer.  0.94. What is the ratio of the Value added (% of GDP) of Manufacturing in 1984 to that in 1987?
Your answer should be very brief. 1.07. What is the ratio of the Value added (% of GDP) of Services in 1984 to that in 1987?
Give a very brief answer. 1.06. What is the ratio of the Value added (% of GDP) of Agriculture in 1984 to that in 1987?
Offer a very short reply. 0.95. What is the ratio of the Value added (% of GDP) of Industry in 1985 to that in 1986?
Provide a succinct answer. 0.95. What is the ratio of the Value added (% of GDP) of Services in 1985 to that in 1986?
Provide a succinct answer. 1.05. What is the ratio of the Value added (% of GDP) in Agriculture in 1985 to that in 1986?
Ensure brevity in your answer.  0.97. What is the ratio of the Value added (% of GDP) of Industry in 1985 to that in 1987?
Your answer should be compact. 0.99. What is the ratio of the Value added (% of GDP) of Manufacturing in 1985 to that in 1987?
Ensure brevity in your answer.  1.04. What is the ratio of the Value added (% of GDP) in Services in 1985 to that in 1987?
Your answer should be very brief. 1.04. What is the ratio of the Value added (% of GDP) in Agriculture in 1985 to that in 1987?
Offer a very short reply. 0.93. What is the ratio of the Value added (% of GDP) in Industry in 1986 to that in 1987?
Give a very brief answer. 1.04. What is the ratio of the Value added (% of GDP) of Manufacturing in 1986 to that in 1987?
Keep it short and to the point. 1.1. What is the ratio of the Value added (% of GDP) in Services in 1986 to that in 1987?
Your answer should be very brief. 0.99. What is the ratio of the Value added (% of GDP) of Agriculture in 1986 to that in 1987?
Offer a terse response. 0.96. What is the difference between the highest and the second highest Value added (% of GDP) of Industry?
Make the answer very short. 1.31. What is the difference between the highest and the second highest Value added (% of GDP) of Manufacturing?
Keep it short and to the point. 0.58. What is the difference between the highest and the second highest Value added (% of GDP) of Services?
Your answer should be compact. 0.39. What is the difference between the highest and the second highest Value added (% of GDP) of Agriculture?
Ensure brevity in your answer.  0.12. What is the difference between the highest and the lowest Value added (% of GDP) of Industry?
Make the answer very short. 5.55. What is the difference between the highest and the lowest Value added (% of GDP) of Manufacturing?
Offer a very short reply. 2.14. What is the difference between the highest and the lowest Value added (% of GDP) of Services?
Offer a terse response. 4.27. What is the difference between the highest and the lowest Value added (% of GDP) of Agriculture?
Make the answer very short. 1.85. 